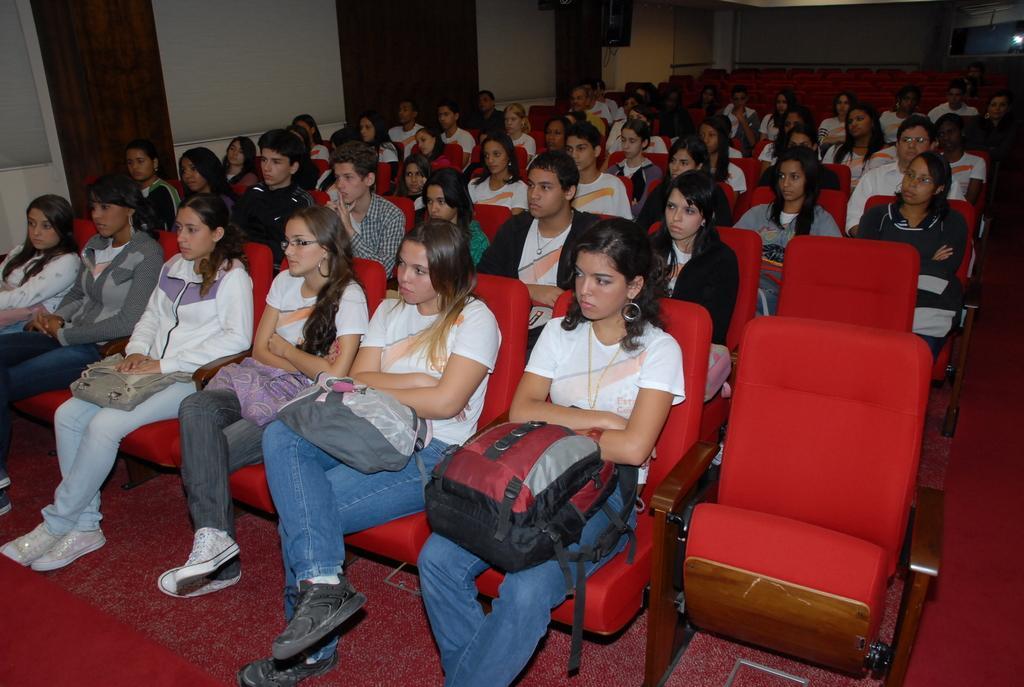In one or two sentences, can you explain what this image depicts? In this image we can see people are sitting on the red chairs. 